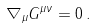<formula> <loc_0><loc_0><loc_500><loc_500>\nabla _ { \mu } G ^ { \mu \nu } = 0 \, .</formula> 